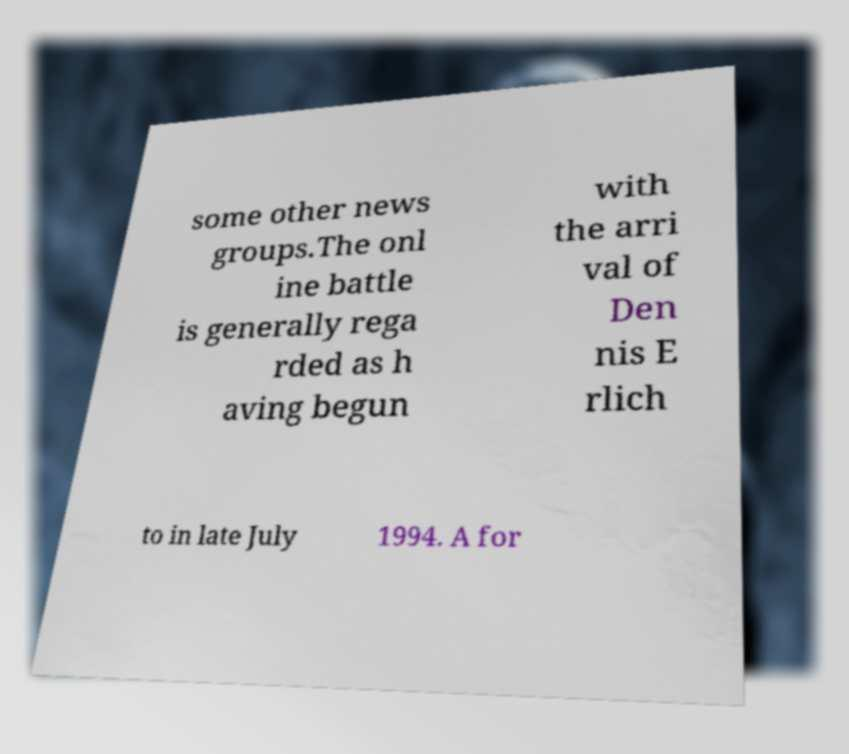Can you read and provide the text displayed in the image?This photo seems to have some interesting text. Can you extract and type it out for me? some other news groups.The onl ine battle is generally rega rded as h aving begun with the arri val of Den nis E rlich to in late July 1994. A for 